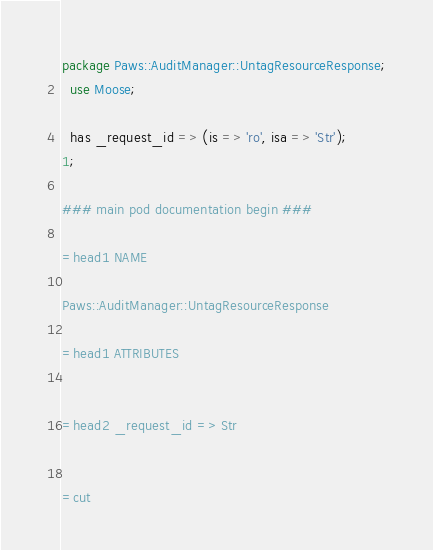Convert code to text. <code><loc_0><loc_0><loc_500><loc_500><_Perl_>
package Paws::AuditManager::UntagResourceResponse;
  use Moose;

  has _request_id => (is => 'ro', isa => 'Str');
1;

### main pod documentation begin ###

=head1 NAME

Paws::AuditManager::UntagResourceResponse

=head1 ATTRIBUTES


=head2 _request_id => Str


=cut

</code> 